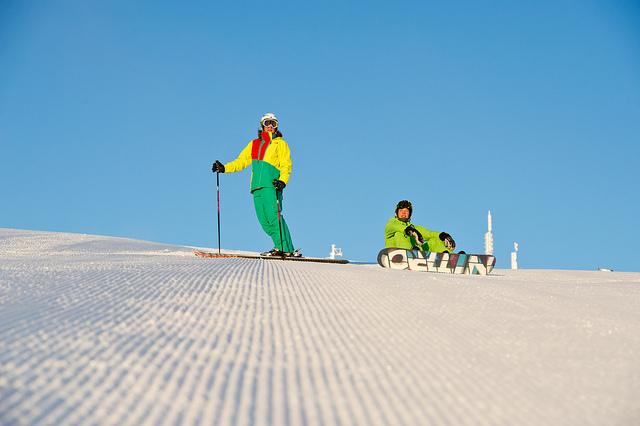What could the condition of the terrain be described as?

Choices:
A) shiny
B) ridged
C) groomed
D) straight groomed 